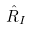<formula> <loc_0><loc_0><loc_500><loc_500>\hat { R } _ { I }</formula> 